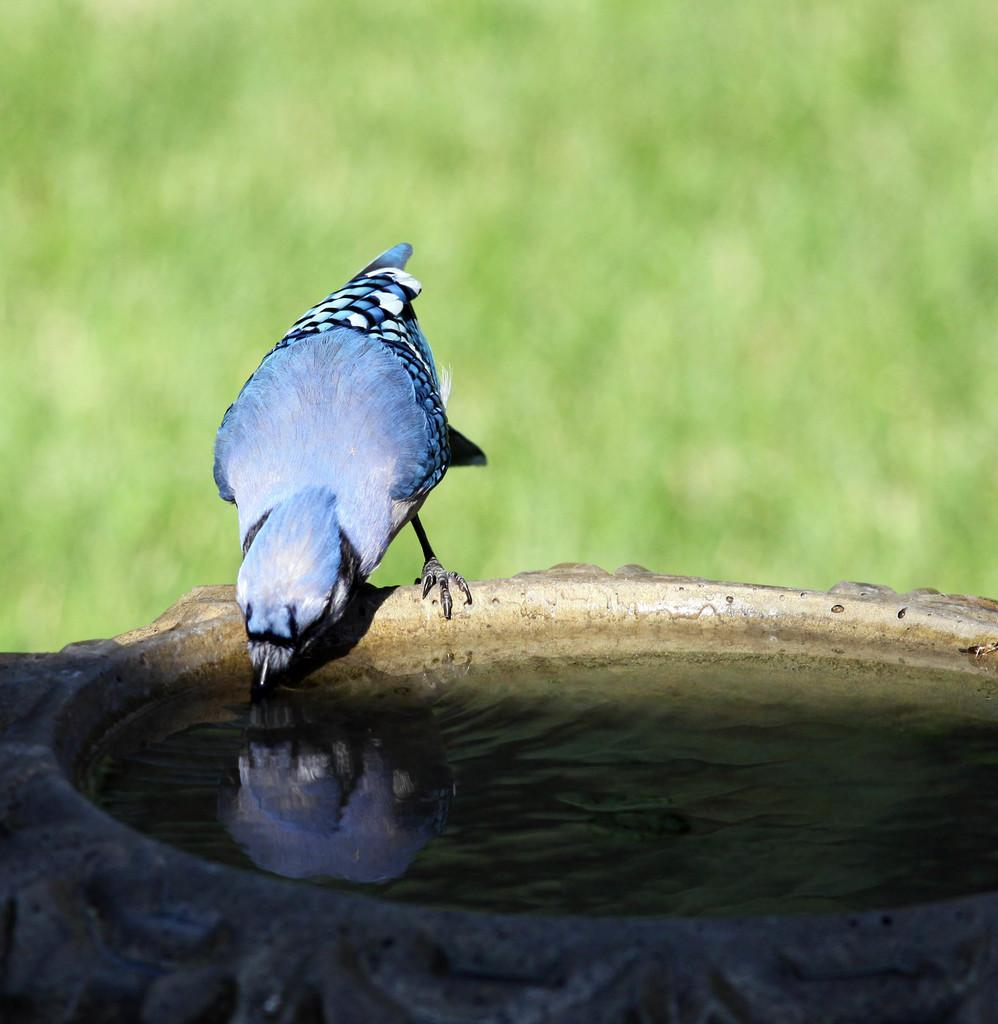What type of animal is in the image? There is a bird in the image. What is the bird doing in the image? The bird is drinking water. Where is the bird located in the image? The bird is on a rock. What color is the background of the image? The background of the image is green. What type of bag is hanging from the bird's beak in the image? There is no bag present in the image; the bird is drinking water. What kind of jelly can be seen dripping from the rock in the image? There is no jelly present in the image; the bird is on a rock. 